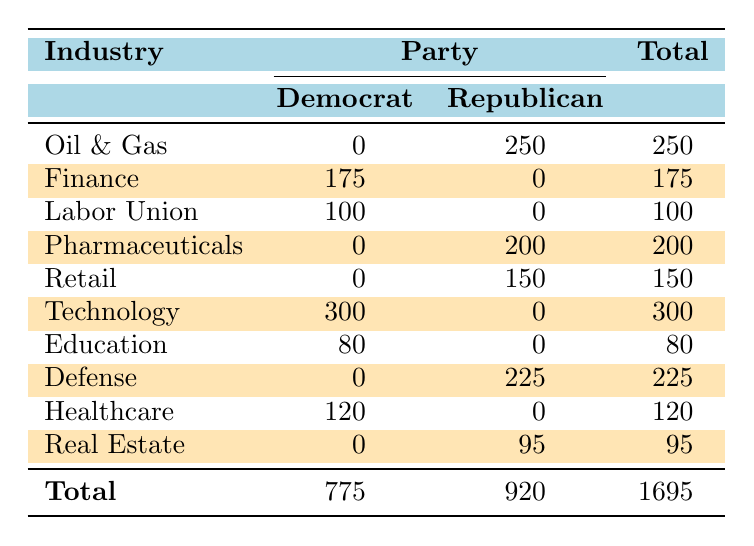What is the total amount contributed by the Oil & Gas industry? According to the table, the entry for the Oil & Gas industry shows a contribution of 250,000 by the Republican Party. Thus, the total amount contributed by this industry is 250,000.
Answer: 250000 Which industry contributed the most to the Democrats? Looking at the table, the Technology industry is listed with a contribution of 300,000 to the Democrat Party, which is higher than any other industry listed for Democrats.
Answer: Technology Is there any contribution from the Labor Union industry to the Republican Party? The table shows that the Labor Union industry contributed 100,000 to the Democrat Party and does not have any entry listed for contributions to the Republican Party.
Answer: No What is the combined total contribution from the Healthcare and Education industries? The Healthcare industry contributed 120,000 and the Education industry contributed 80,000. Adding these together gives 120,000 + 80,000 = 200,000 for the combined total contribution.
Answer: 200000 Which party received the highest total contributions? The total contributions for the Democrat Party amount to 775,000, while the Republican Party received 920,000. Since 920,000 is greater than 775,000, the Republican Party received higher total contributions.
Answer: Republican What percentage of total contributions came from the Technology industry? The Technology industry contributed 300,000 and the total contributions amount to 1,695,000. To find the percentage, use the formula (300,000 / 1,695,000) * 100, which approximately equals 17.7%.
Answer: 17.7% Did any candidate from the Retail industry receive contributions from the Democrat party? The Retail industry has a recorded contribution of 150,000 directed solely to the Republican Party, with no entries for Democrat contributions.
Answer: No What is the average contribution amount for industries that contributed to both parties? The industries contributing to both parties are Oil & Gas, Finance, and Defense. Their contributions are 250,000 (Republican), 175,000 (Democrat), and 225,000 (Republican respectively). The total contributions are 250,000 + 0 + 225,000 = 475,000 for Republican and 175,000 + 0 + 0 = 175,000 for Democrat, and the average is (475,000 + 175,000) / 3 = 217,000.
Answer: 217000 